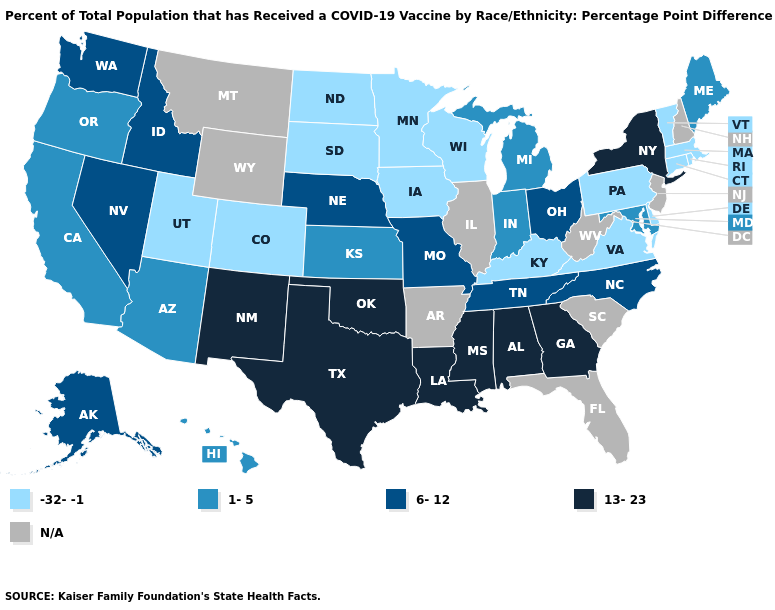Name the states that have a value in the range N/A?
Write a very short answer. Arkansas, Florida, Illinois, Montana, New Hampshire, New Jersey, South Carolina, West Virginia, Wyoming. What is the value of Maine?
Write a very short answer. 1-5. Name the states that have a value in the range 1-5?
Give a very brief answer. Arizona, California, Hawaii, Indiana, Kansas, Maine, Maryland, Michigan, Oregon. What is the value of Oregon?
Give a very brief answer. 1-5. How many symbols are there in the legend?
Quick response, please. 5. Which states have the lowest value in the West?
Answer briefly. Colorado, Utah. Among the states that border Michigan , does Wisconsin have the lowest value?
Short answer required. Yes. Name the states that have a value in the range 1-5?
Quick response, please. Arizona, California, Hawaii, Indiana, Kansas, Maine, Maryland, Michigan, Oregon. Which states hav the highest value in the Northeast?
Short answer required. New York. What is the value of Georgia?
Concise answer only. 13-23. Which states have the highest value in the USA?
Give a very brief answer. Alabama, Georgia, Louisiana, Mississippi, New Mexico, New York, Oklahoma, Texas. 